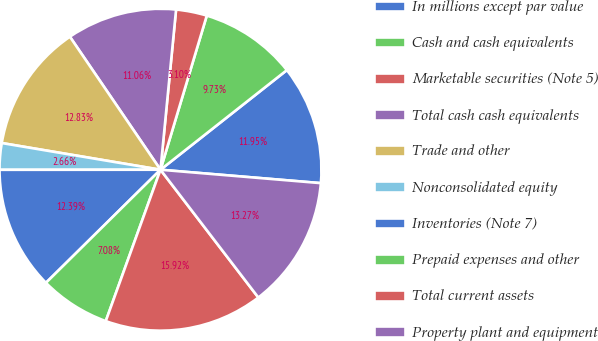Convert chart. <chart><loc_0><loc_0><loc_500><loc_500><pie_chart><fcel>In millions except par value<fcel>Cash and cash equivalents<fcel>Marketable securities (Note 5)<fcel>Total cash cash equivalents<fcel>Trade and other<fcel>Nonconsolidated equity<fcel>Inventories (Note 7)<fcel>Prepaid expenses and other<fcel>Total current assets<fcel>Property plant and equipment<nl><fcel>11.95%<fcel>9.73%<fcel>3.1%<fcel>11.06%<fcel>12.83%<fcel>2.66%<fcel>12.39%<fcel>7.08%<fcel>15.92%<fcel>13.27%<nl></chart> 